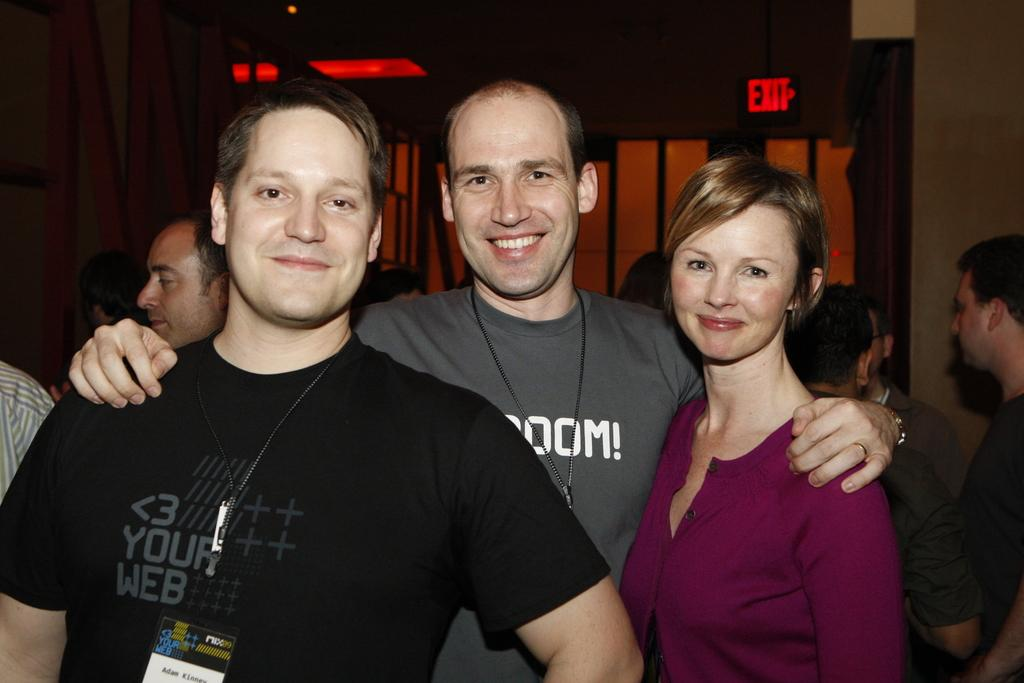How many people are in the image? There are three people standing in the image. What is the facial expression of the people in the image? The people are smiling. What can be seen behind the people in the image? There is a background visible in the image, which includes a wall and a board. Are there any other people visible in the image? Yes, people are present in the background. What type of education can be seen on the shelf in the image? There is no shelf present in the image, and therefore no education-related items can be observed. 